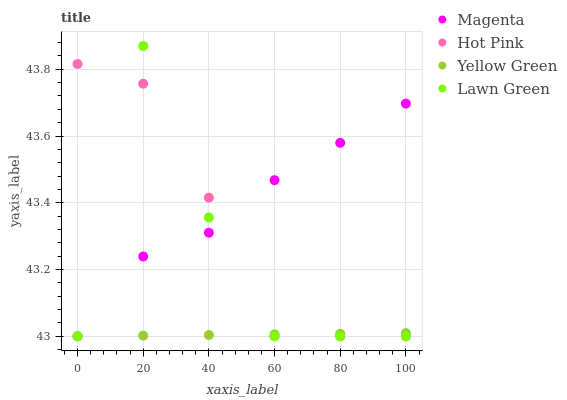Does Yellow Green have the minimum area under the curve?
Answer yes or no. Yes. Does Magenta have the maximum area under the curve?
Answer yes or no. Yes. Does Hot Pink have the minimum area under the curve?
Answer yes or no. No. Does Hot Pink have the maximum area under the curve?
Answer yes or no. No. Is Yellow Green the smoothest?
Answer yes or no. Yes. Is Lawn Green the roughest?
Answer yes or no. Yes. Is Magenta the smoothest?
Answer yes or no. No. Is Magenta the roughest?
Answer yes or no. No. Does Lawn Green have the lowest value?
Answer yes or no. Yes. Does Lawn Green have the highest value?
Answer yes or no. Yes. Does Magenta have the highest value?
Answer yes or no. No. Does Yellow Green intersect Lawn Green?
Answer yes or no. Yes. Is Yellow Green less than Lawn Green?
Answer yes or no. No. Is Yellow Green greater than Lawn Green?
Answer yes or no. No. 